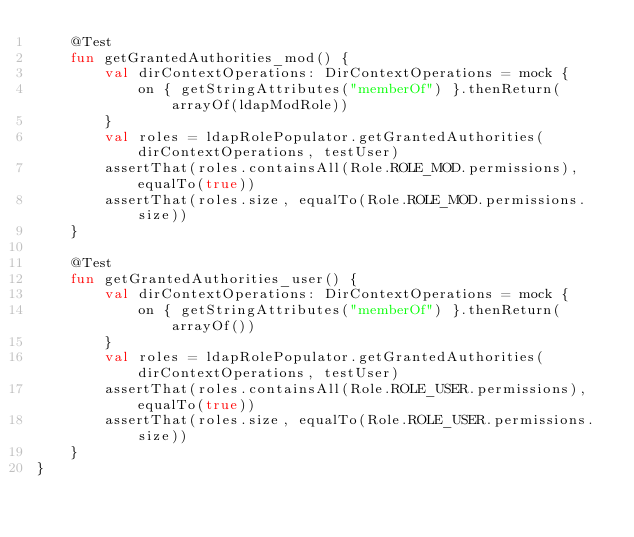<code> <loc_0><loc_0><loc_500><loc_500><_Kotlin_>    @Test
    fun getGrantedAuthorities_mod() {
        val dirContextOperations: DirContextOperations = mock {
            on { getStringAttributes("memberOf") }.thenReturn(arrayOf(ldapModRole))
        }
        val roles = ldapRolePopulator.getGrantedAuthorities(dirContextOperations, testUser)
        assertThat(roles.containsAll(Role.ROLE_MOD.permissions), equalTo(true))
        assertThat(roles.size, equalTo(Role.ROLE_MOD.permissions.size))
    }

    @Test
    fun getGrantedAuthorities_user() {
        val dirContextOperations: DirContextOperations = mock {
            on { getStringAttributes("memberOf") }.thenReturn(arrayOf())
        }
        val roles = ldapRolePopulator.getGrantedAuthorities(dirContextOperations, testUser)
        assertThat(roles.containsAll(Role.ROLE_USER.permissions), equalTo(true))
        assertThat(roles.size, equalTo(Role.ROLE_USER.permissions.size))
    }
}
</code> 